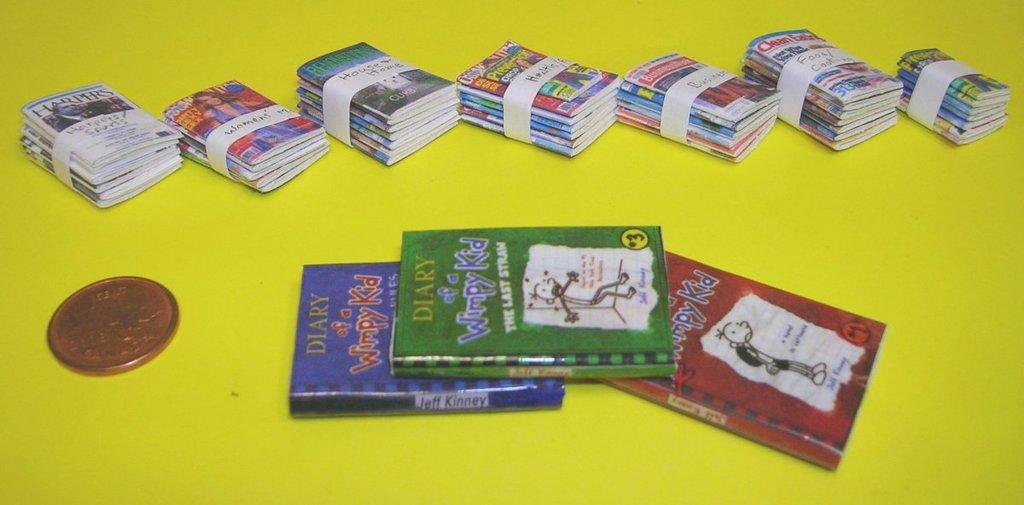<image>
Write a terse but informative summary of the picture. Seven stacks of paperback books behind four Diary of a Wimpy Kid books. 